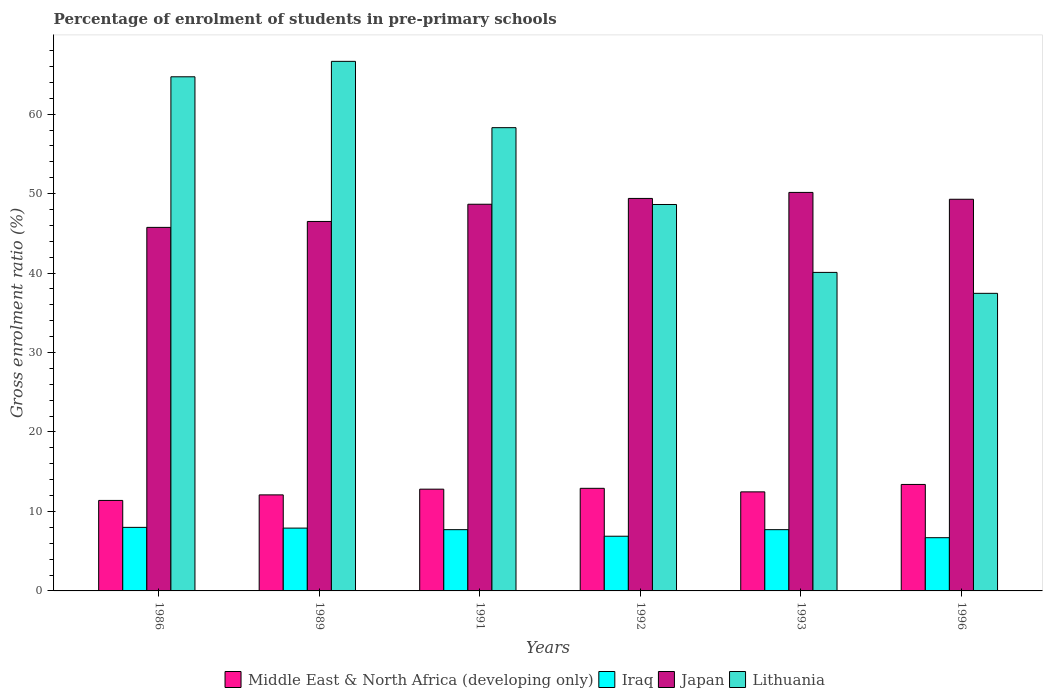How many different coloured bars are there?
Give a very brief answer. 4. Are the number of bars on each tick of the X-axis equal?
Offer a terse response. Yes. How many bars are there on the 2nd tick from the right?
Give a very brief answer. 4. What is the label of the 1st group of bars from the left?
Keep it short and to the point. 1986. What is the percentage of students enrolled in pre-primary schools in Lithuania in 1991?
Give a very brief answer. 58.29. Across all years, what is the maximum percentage of students enrolled in pre-primary schools in Japan?
Give a very brief answer. 50.15. Across all years, what is the minimum percentage of students enrolled in pre-primary schools in Lithuania?
Your answer should be very brief. 37.45. In which year was the percentage of students enrolled in pre-primary schools in Iraq maximum?
Make the answer very short. 1986. In which year was the percentage of students enrolled in pre-primary schools in Middle East & North Africa (developing only) minimum?
Your answer should be very brief. 1986. What is the total percentage of students enrolled in pre-primary schools in Japan in the graph?
Give a very brief answer. 289.72. What is the difference between the percentage of students enrolled in pre-primary schools in Japan in 1989 and that in 1996?
Ensure brevity in your answer.  -2.79. What is the difference between the percentage of students enrolled in pre-primary schools in Lithuania in 1992 and the percentage of students enrolled in pre-primary schools in Japan in 1993?
Provide a short and direct response. -1.52. What is the average percentage of students enrolled in pre-primary schools in Middle East & North Africa (developing only) per year?
Your response must be concise. 12.51. In the year 1996, what is the difference between the percentage of students enrolled in pre-primary schools in Iraq and percentage of students enrolled in pre-primary schools in Middle East & North Africa (developing only)?
Ensure brevity in your answer.  -6.7. In how many years, is the percentage of students enrolled in pre-primary schools in Japan greater than 16 %?
Give a very brief answer. 6. What is the ratio of the percentage of students enrolled in pre-primary schools in Iraq in 1989 to that in 1992?
Ensure brevity in your answer.  1.15. Is the percentage of students enrolled in pre-primary schools in Lithuania in 1986 less than that in 1992?
Provide a succinct answer. No. Is the difference between the percentage of students enrolled in pre-primary schools in Iraq in 1991 and 1992 greater than the difference between the percentage of students enrolled in pre-primary schools in Middle East & North Africa (developing only) in 1991 and 1992?
Your answer should be very brief. Yes. What is the difference between the highest and the second highest percentage of students enrolled in pre-primary schools in Japan?
Make the answer very short. 0.76. What is the difference between the highest and the lowest percentage of students enrolled in pre-primary schools in Middle East & North Africa (developing only)?
Your response must be concise. 2.01. In how many years, is the percentage of students enrolled in pre-primary schools in Japan greater than the average percentage of students enrolled in pre-primary schools in Japan taken over all years?
Your response must be concise. 4. What does the 4th bar from the left in 1993 represents?
Ensure brevity in your answer.  Lithuania. What does the 3rd bar from the right in 1986 represents?
Your answer should be very brief. Iraq. How many bars are there?
Your answer should be very brief. 24. Are all the bars in the graph horizontal?
Offer a terse response. No. What is the difference between two consecutive major ticks on the Y-axis?
Your response must be concise. 10. Where does the legend appear in the graph?
Offer a very short reply. Bottom center. How are the legend labels stacked?
Your response must be concise. Horizontal. What is the title of the graph?
Keep it short and to the point. Percentage of enrolment of students in pre-primary schools. Does "Austria" appear as one of the legend labels in the graph?
Your answer should be very brief. No. What is the label or title of the X-axis?
Provide a short and direct response. Years. What is the label or title of the Y-axis?
Your response must be concise. Gross enrolment ratio (%). What is the Gross enrolment ratio (%) in Middle East & North Africa (developing only) in 1986?
Provide a short and direct response. 11.39. What is the Gross enrolment ratio (%) in Iraq in 1986?
Offer a very short reply. 8. What is the Gross enrolment ratio (%) of Japan in 1986?
Provide a short and direct response. 45.75. What is the Gross enrolment ratio (%) in Lithuania in 1986?
Offer a terse response. 64.7. What is the Gross enrolment ratio (%) in Middle East & North Africa (developing only) in 1989?
Your answer should be compact. 12.09. What is the Gross enrolment ratio (%) of Iraq in 1989?
Your answer should be very brief. 7.91. What is the Gross enrolment ratio (%) in Japan in 1989?
Make the answer very short. 46.49. What is the Gross enrolment ratio (%) in Lithuania in 1989?
Your answer should be very brief. 66.64. What is the Gross enrolment ratio (%) in Middle East & North Africa (developing only) in 1991?
Keep it short and to the point. 12.8. What is the Gross enrolment ratio (%) of Iraq in 1991?
Keep it short and to the point. 7.71. What is the Gross enrolment ratio (%) in Japan in 1991?
Give a very brief answer. 48.66. What is the Gross enrolment ratio (%) of Lithuania in 1991?
Make the answer very short. 58.29. What is the Gross enrolment ratio (%) of Middle East & North Africa (developing only) in 1992?
Your answer should be very brief. 12.91. What is the Gross enrolment ratio (%) in Iraq in 1992?
Offer a very short reply. 6.88. What is the Gross enrolment ratio (%) in Japan in 1992?
Keep it short and to the point. 49.39. What is the Gross enrolment ratio (%) of Lithuania in 1992?
Make the answer very short. 48.63. What is the Gross enrolment ratio (%) in Middle East & North Africa (developing only) in 1993?
Your answer should be compact. 12.47. What is the Gross enrolment ratio (%) in Iraq in 1993?
Your response must be concise. 7.71. What is the Gross enrolment ratio (%) of Japan in 1993?
Give a very brief answer. 50.15. What is the Gross enrolment ratio (%) in Lithuania in 1993?
Offer a terse response. 40.08. What is the Gross enrolment ratio (%) in Middle East & North Africa (developing only) in 1996?
Offer a terse response. 13.4. What is the Gross enrolment ratio (%) of Iraq in 1996?
Ensure brevity in your answer.  6.7. What is the Gross enrolment ratio (%) in Japan in 1996?
Keep it short and to the point. 49.29. What is the Gross enrolment ratio (%) of Lithuania in 1996?
Keep it short and to the point. 37.45. Across all years, what is the maximum Gross enrolment ratio (%) in Middle East & North Africa (developing only)?
Your answer should be compact. 13.4. Across all years, what is the maximum Gross enrolment ratio (%) of Iraq?
Offer a very short reply. 8. Across all years, what is the maximum Gross enrolment ratio (%) of Japan?
Ensure brevity in your answer.  50.15. Across all years, what is the maximum Gross enrolment ratio (%) of Lithuania?
Give a very brief answer. 66.64. Across all years, what is the minimum Gross enrolment ratio (%) of Middle East & North Africa (developing only)?
Make the answer very short. 11.39. Across all years, what is the minimum Gross enrolment ratio (%) in Iraq?
Your answer should be compact. 6.7. Across all years, what is the minimum Gross enrolment ratio (%) in Japan?
Keep it short and to the point. 45.75. Across all years, what is the minimum Gross enrolment ratio (%) of Lithuania?
Provide a succinct answer. 37.45. What is the total Gross enrolment ratio (%) of Middle East & North Africa (developing only) in the graph?
Ensure brevity in your answer.  75.05. What is the total Gross enrolment ratio (%) in Iraq in the graph?
Give a very brief answer. 44.9. What is the total Gross enrolment ratio (%) of Japan in the graph?
Your answer should be very brief. 289.72. What is the total Gross enrolment ratio (%) in Lithuania in the graph?
Make the answer very short. 315.79. What is the difference between the Gross enrolment ratio (%) of Middle East & North Africa (developing only) in 1986 and that in 1989?
Your answer should be very brief. -0.7. What is the difference between the Gross enrolment ratio (%) of Iraq in 1986 and that in 1989?
Provide a succinct answer. 0.09. What is the difference between the Gross enrolment ratio (%) of Japan in 1986 and that in 1989?
Offer a terse response. -0.75. What is the difference between the Gross enrolment ratio (%) of Lithuania in 1986 and that in 1989?
Offer a terse response. -1.94. What is the difference between the Gross enrolment ratio (%) in Middle East & North Africa (developing only) in 1986 and that in 1991?
Provide a succinct answer. -1.42. What is the difference between the Gross enrolment ratio (%) of Iraq in 1986 and that in 1991?
Ensure brevity in your answer.  0.29. What is the difference between the Gross enrolment ratio (%) in Japan in 1986 and that in 1991?
Provide a succinct answer. -2.91. What is the difference between the Gross enrolment ratio (%) of Lithuania in 1986 and that in 1991?
Your answer should be very brief. 6.4. What is the difference between the Gross enrolment ratio (%) of Middle East & North Africa (developing only) in 1986 and that in 1992?
Ensure brevity in your answer.  -1.52. What is the difference between the Gross enrolment ratio (%) in Iraq in 1986 and that in 1992?
Your answer should be compact. 1.12. What is the difference between the Gross enrolment ratio (%) of Japan in 1986 and that in 1992?
Keep it short and to the point. -3.64. What is the difference between the Gross enrolment ratio (%) of Lithuania in 1986 and that in 1992?
Provide a short and direct response. 16.07. What is the difference between the Gross enrolment ratio (%) of Middle East & North Africa (developing only) in 1986 and that in 1993?
Keep it short and to the point. -1.08. What is the difference between the Gross enrolment ratio (%) of Iraq in 1986 and that in 1993?
Offer a very short reply. 0.29. What is the difference between the Gross enrolment ratio (%) in Japan in 1986 and that in 1993?
Provide a succinct answer. -4.4. What is the difference between the Gross enrolment ratio (%) in Lithuania in 1986 and that in 1993?
Provide a succinct answer. 24.61. What is the difference between the Gross enrolment ratio (%) in Middle East & North Africa (developing only) in 1986 and that in 1996?
Offer a terse response. -2.01. What is the difference between the Gross enrolment ratio (%) in Iraq in 1986 and that in 1996?
Give a very brief answer. 1.3. What is the difference between the Gross enrolment ratio (%) of Japan in 1986 and that in 1996?
Your answer should be compact. -3.54. What is the difference between the Gross enrolment ratio (%) of Lithuania in 1986 and that in 1996?
Keep it short and to the point. 27.25. What is the difference between the Gross enrolment ratio (%) of Middle East & North Africa (developing only) in 1989 and that in 1991?
Offer a very short reply. -0.72. What is the difference between the Gross enrolment ratio (%) of Iraq in 1989 and that in 1991?
Your answer should be very brief. 0.2. What is the difference between the Gross enrolment ratio (%) in Japan in 1989 and that in 1991?
Offer a terse response. -2.17. What is the difference between the Gross enrolment ratio (%) in Lithuania in 1989 and that in 1991?
Offer a terse response. 8.35. What is the difference between the Gross enrolment ratio (%) of Middle East & North Africa (developing only) in 1989 and that in 1992?
Provide a succinct answer. -0.83. What is the difference between the Gross enrolment ratio (%) in Iraq in 1989 and that in 1992?
Ensure brevity in your answer.  1.02. What is the difference between the Gross enrolment ratio (%) in Japan in 1989 and that in 1992?
Provide a succinct answer. -2.9. What is the difference between the Gross enrolment ratio (%) in Lithuania in 1989 and that in 1992?
Offer a very short reply. 18.01. What is the difference between the Gross enrolment ratio (%) in Middle East & North Africa (developing only) in 1989 and that in 1993?
Your answer should be very brief. -0.38. What is the difference between the Gross enrolment ratio (%) in Iraq in 1989 and that in 1993?
Keep it short and to the point. 0.2. What is the difference between the Gross enrolment ratio (%) of Japan in 1989 and that in 1993?
Ensure brevity in your answer.  -3.65. What is the difference between the Gross enrolment ratio (%) of Lithuania in 1989 and that in 1993?
Ensure brevity in your answer.  26.56. What is the difference between the Gross enrolment ratio (%) in Middle East & North Africa (developing only) in 1989 and that in 1996?
Offer a very short reply. -1.31. What is the difference between the Gross enrolment ratio (%) of Iraq in 1989 and that in 1996?
Your answer should be compact. 1.21. What is the difference between the Gross enrolment ratio (%) of Japan in 1989 and that in 1996?
Offer a very short reply. -2.79. What is the difference between the Gross enrolment ratio (%) in Lithuania in 1989 and that in 1996?
Offer a very short reply. 29.19. What is the difference between the Gross enrolment ratio (%) of Middle East & North Africa (developing only) in 1991 and that in 1992?
Your response must be concise. -0.11. What is the difference between the Gross enrolment ratio (%) in Iraq in 1991 and that in 1992?
Offer a very short reply. 0.83. What is the difference between the Gross enrolment ratio (%) of Japan in 1991 and that in 1992?
Give a very brief answer. -0.73. What is the difference between the Gross enrolment ratio (%) in Lithuania in 1991 and that in 1992?
Your answer should be compact. 9.67. What is the difference between the Gross enrolment ratio (%) in Middle East & North Africa (developing only) in 1991 and that in 1993?
Offer a terse response. 0.34. What is the difference between the Gross enrolment ratio (%) in Iraq in 1991 and that in 1993?
Ensure brevity in your answer.  0. What is the difference between the Gross enrolment ratio (%) of Japan in 1991 and that in 1993?
Offer a very short reply. -1.49. What is the difference between the Gross enrolment ratio (%) of Lithuania in 1991 and that in 1993?
Provide a succinct answer. 18.21. What is the difference between the Gross enrolment ratio (%) of Middle East & North Africa (developing only) in 1991 and that in 1996?
Your answer should be very brief. -0.59. What is the difference between the Gross enrolment ratio (%) of Japan in 1991 and that in 1996?
Offer a terse response. -0.63. What is the difference between the Gross enrolment ratio (%) of Lithuania in 1991 and that in 1996?
Provide a short and direct response. 20.85. What is the difference between the Gross enrolment ratio (%) in Middle East & North Africa (developing only) in 1992 and that in 1993?
Offer a terse response. 0.45. What is the difference between the Gross enrolment ratio (%) of Iraq in 1992 and that in 1993?
Provide a short and direct response. -0.83. What is the difference between the Gross enrolment ratio (%) in Japan in 1992 and that in 1993?
Provide a succinct answer. -0.76. What is the difference between the Gross enrolment ratio (%) of Lithuania in 1992 and that in 1993?
Make the answer very short. 8.54. What is the difference between the Gross enrolment ratio (%) of Middle East & North Africa (developing only) in 1992 and that in 1996?
Your answer should be very brief. -0.49. What is the difference between the Gross enrolment ratio (%) of Iraq in 1992 and that in 1996?
Offer a terse response. 0.18. What is the difference between the Gross enrolment ratio (%) in Japan in 1992 and that in 1996?
Your answer should be compact. 0.1. What is the difference between the Gross enrolment ratio (%) in Lithuania in 1992 and that in 1996?
Provide a short and direct response. 11.18. What is the difference between the Gross enrolment ratio (%) in Middle East & North Africa (developing only) in 1993 and that in 1996?
Provide a short and direct response. -0.93. What is the difference between the Gross enrolment ratio (%) of Iraq in 1993 and that in 1996?
Provide a succinct answer. 1.01. What is the difference between the Gross enrolment ratio (%) of Japan in 1993 and that in 1996?
Offer a very short reply. 0.86. What is the difference between the Gross enrolment ratio (%) of Lithuania in 1993 and that in 1996?
Offer a terse response. 2.63. What is the difference between the Gross enrolment ratio (%) of Middle East & North Africa (developing only) in 1986 and the Gross enrolment ratio (%) of Iraq in 1989?
Keep it short and to the point. 3.48. What is the difference between the Gross enrolment ratio (%) in Middle East & North Africa (developing only) in 1986 and the Gross enrolment ratio (%) in Japan in 1989?
Provide a succinct answer. -35.11. What is the difference between the Gross enrolment ratio (%) in Middle East & North Africa (developing only) in 1986 and the Gross enrolment ratio (%) in Lithuania in 1989?
Provide a succinct answer. -55.25. What is the difference between the Gross enrolment ratio (%) of Iraq in 1986 and the Gross enrolment ratio (%) of Japan in 1989?
Keep it short and to the point. -38.5. What is the difference between the Gross enrolment ratio (%) in Iraq in 1986 and the Gross enrolment ratio (%) in Lithuania in 1989?
Provide a succinct answer. -58.64. What is the difference between the Gross enrolment ratio (%) in Japan in 1986 and the Gross enrolment ratio (%) in Lithuania in 1989?
Your response must be concise. -20.89. What is the difference between the Gross enrolment ratio (%) of Middle East & North Africa (developing only) in 1986 and the Gross enrolment ratio (%) of Iraq in 1991?
Provide a succinct answer. 3.68. What is the difference between the Gross enrolment ratio (%) in Middle East & North Africa (developing only) in 1986 and the Gross enrolment ratio (%) in Japan in 1991?
Your answer should be compact. -37.27. What is the difference between the Gross enrolment ratio (%) in Middle East & North Africa (developing only) in 1986 and the Gross enrolment ratio (%) in Lithuania in 1991?
Your answer should be compact. -46.91. What is the difference between the Gross enrolment ratio (%) in Iraq in 1986 and the Gross enrolment ratio (%) in Japan in 1991?
Offer a very short reply. -40.66. What is the difference between the Gross enrolment ratio (%) of Iraq in 1986 and the Gross enrolment ratio (%) of Lithuania in 1991?
Give a very brief answer. -50.3. What is the difference between the Gross enrolment ratio (%) in Japan in 1986 and the Gross enrolment ratio (%) in Lithuania in 1991?
Provide a short and direct response. -12.55. What is the difference between the Gross enrolment ratio (%) of Middle East & North Africa (developing only) in 1986 and the Gross enrolment ratio (%) of Iraq in 1992?
Make the answer very short. 4.51. What is the difference between the Gross enrolment ratio (%) of Middle East & North Africa (developing only) in 1986 and the Gross enrolment ratio (%) of Japan in 1992?
Provide a short and direct response. -38. What is the difference between the Gross enrolment ratio (%) of Middle East & North Africa (developing only) in 1986 and the Gross enrolment ratio (%) of Lithuania in 1992?
Make the answer very short. -37.24. What is the difference between the Gross enrolment ratio (%) in Iraq in 1986 and the Gross enrolment ratio (%) in Japan in 1992?
Make the answer very short. -41.39. What is the difference between the Gross enrolment ratio (%) of Iraq in 1986 and the Gross enrolment ratio (%) of Lithuania in 1992?
Give a very brief answer. -40.63. What is the difference between the Gross enrolment ratio (%) of Japan in 1986 and the Gross enrolment ratio (%) of Lithuania in 1992?
Provide a short and direct response. -2.88. What is the difference between the Gross enrolment ratio (%) of Middle East & North Africa (developing only) in 1986 and the Gross enrolment ratio (%) of Iraq in 1993?
Your answer should be very brief. 3.68. What is the difference between the Gross enrolment ratio (%) of Middle East & North Africa (developing only) in 1986 and the Gross enrolment ratio (%) of Japan in 1993?
Provide a succinct answer. -38.76. What is the difference between the Gross enrolment ratio (%) of Middle East & North Africa (developing only) in 1986 and the Gross enrolment ratio (%) of Lithuania in 1993?
Your answer should be very brief. -28.69. What is the difference between the Gross enrolment ratio (%) in Iraq in 1986 and the Gross enrolment ratio (%) in Japan in 1993?
Your answer should be compact. -42.15. What is the difference between the Gross enrolment ratio (%) in Iraq in 1986 and the Gross enrolment ratio (%) in Lithuania in 1993?
Your answer should be compact. -32.09. What is the difference between the Gross enrolment ratio (%) in Japan in 1986 and the Gross enrolment ratio (%) in Lithuania in 1993?
Provide a succinct answer. 5.66. What is the difference between the Gross enrolment ratio (%) of Middle East & North Africa (developing only) in 1986 and the Gross enrolment ratio (%) of Iraq in 1996?
Provide a short and direct response. 4.69. What is the difference between the Gross enrolment ratio (%) of Middle East & North Africa (developing only) in 1986 and the Gross enrolment ratio (%) of Japan in 1996?
Your response must be concise. -37.9. What is the difference between the Gross enrolment ratio (%) in Middle East & North Africa (developing only) in 1986 and the Gross enrolment ratio (%) in Lithuania in 1996?
Provide a succinct answer. -26.06. What is the difference between the Gross enrolment ratio (%) in Iraq in 1986 and the Gross enrolment ratio (%) in Japan in 1996?
Provide a short and direct response. -41.29. What is the difference between the Gross enrolment ratio (%) of Iraq in 1986 and the Gross enrolment ratio (%) of Lithuania in 1996?
Your answer should be compact. -29.45. What is the difference between the Gross enrolment ratio (%) of Japan in 1986 and the Gross enrolment ratio (%) of Lithuania in 1996?
Ensure brevity in your answer.  8.3. What is the difference between the Gross enrolment ratio (%) of Middle East & North Africa (developing only) in 1989 and the Gross enrolment ratio (%) of Iraq in 1991?
Your answer should be very brief. 4.38. What is the difference between the Gross enrolment ratio (%) in Middle East & North Africa (developing only) in 1989 and the Gross enrolment ratio (%) in Japan in 1991?
Provide a succinct answer. -36.57. What is the difference between the Gross enrolment ratio (%) of Middle East & North Africa (developing only) in 1989 and the Gross enrolment ratio (%) of Lithuania in 1991?
Your answer should be compact. -46.21. What is the difference between the Gross enrolment ratio (%) of Iraq in 1989 and the Gross enrolment ratio (%) of Japan in 1991?
Offer a terse response. -40.75. What is the difference between the Gross enrolment ratio (%) in Iraq in 1989 and the Gross enrolment ratio (%) in Lithuania in 1991?
Your response must be concise. -50.39. What is the difference between the Gross enrolment ratio (%) of Japan in 1989 and the Gross enrolment ratio (%) of Lithuania in 1991?
Offer a terse response. -11.8. What is the difference between the Gross enrolment ratio (%) of Middle East & North Africa (developing only) in 1989 and the Gross enrolment ratio (%) of Iraq in 1992?
Ensure brevity in your answer.  5.2. What is the difference between the Gross enrolment ratio (%) of Middle East & North Africa (developing only) in 1989 and the Gross enrolment ratio (%) of Japan in 1992?
Ensure brevity in your answer.  -37.3. What is the difference between the Gross enrolment ratio (%) of Middle East & North Africa (developing only) in 1989 and the Gross enrolment ratio (%) of Lithuania in 1992?
Your answer should be compact. -36.54. What is the difference between the Gross enrolment ratio (%) in Iraq in 1989 and the Gross enrolment ratio (%) in Japan in 1992?
Offer a terse response. -41.48. What is the difference between the Gross enrolment ratio (%) of Iraq in 1989 and the Gross enrolment ratio (%) of Lithuania in 1992?
Provide a short and direct response. -40.72. What is the difference between the Gross enrolment ratio (%) in Japan in 1989 and the Gross enrolment ratio (%) in Lithuania in 1992?
Make the answer very short. -2.13. What is the difference between the Gross enrolment ratio (%) of Middle East & North Africa (developing only) in 1989 and the Gross enrolment ratio (%) of Iraq in 1993?
Offer a terse response. 4.38. What is the difference between the Gross enrolment ratio (%) in Middle East & North Africa (developing only) in 1989 and the Gross enrolment ratio (%) in Japan in 1993?
Offer a terse response. -38.06. What is the difference between the Gross enrolment ratio (%) of Middle East & North Africa (developing only) in 1989 and the Gross enrolment ratio (%) of Lithuania in 1993?
Keep it short and to the point. -28. What is the difference between the Gross enrolment ratio (%) of Iraq in 1989 and the Gross enrolment ratio (%) of Japan in 1993?
Provide a short and direct response. -42.24. What is the difference between the Gross enrolment ratio (%) of Iraq in 1989 and the Gross enrolment ratio (%) of Lithuania in 1993?
Give a very brief answer. -32.18. What is the difference between the Gross enrolment ratio (%) of Japan in 1989 and the Gross enrolment ratio (%) of Lithuania in 1993?
Offer a very short reply. 6.41. What is the difference between the Gross enrolment ratio (%) in Middle East & North Africa (developing only) in 1989 and the Gross enrolment ratio (%) in Iraq in 1996?
Give a very brief answer. 5.39. What is the difference between the Gross enrolment ratio (%) of Middle East & North Africa (developing only) in 1989 and the Gross enrolment ratio (%) of Japan in 1996?
Your response must be concise. -37.2. What is the difference between the Gross enrolment ratio (%) of Middle East & North Africa (developing only) in 1989 and the Gross enrolment ratio (%) of Lithuania in 1996?
Give a very brief answer. -25.36. What is the difference between the Gross enrolment ratio (%) of Iraq in 1989 and the Gross enrolment ratio (%) of Japan in 1996?
Offer a very short reply. -41.38. What is the difference between the Gross enrolment ratio (%) in Iraq in 1989 and the Gross enrolment ratio (%) in Lithuania in 1996?
Your response must be concise. -29.54. What is the difference between the Gross enrolment ratio (%) of Japan in 1989 and the Gross enrolment ratio (%) of Lithuania in 1996?
Ensure brevity in your answer.  9.05. What is the difference between the Gross enrolment ratio (%) of Middle East & North Africa (developing only) in 1991 and the Gross enrolment ratio (%) of Iraq in 1992?
Ensure brevity in your answer.  5.92. What is the difference between the Gross enrolment ratio (%) in Middle East & North Africa (developing only) in 1991 and the Gross enrolment ratio (%) in Japan in 1992?
Offer a very short reply. -36.59. What is the difference between the Gross enrolment ratio (%) of Middle East & North Africa (developing only) in 1991 and the Gross enrolment ratio (%) of Lithuania in 1992?
Your answer should be very brief. -35.82. What is the difference between the Gross enrolment ratio (%) of Iraq in 1991 and the Gross enrolment ratio (%) of Japan in 1992?
Offer a very short reply. -41.68. What is the difference between the Gross enrolment ratio (%) in Iraq in 1991 and the Gross enrolment ratio (%) in Lithuania in 1992?
Offer a terse response. -40.92. What is the difference between the Gross enrolment ratio (%) of Japan in 1991 and the Gross enrolment ratio (%) of Lithuania in 1992?
Ensure brevity in your answer.  0.03. What is the difference between the Gross enrolment ratio (%) in Middle East & North Africa (developing only) in 1991 and the Gross enrolment ratio (%) in Iraq in 1993?
Offer a terse response. 5.1. What is the difference between the Gross enrolment ratio (%) in Middle East & North Africa (developing only) in 1991 and the Gross enrolment ratio (%) in Japan in 1993?
Offer a very short reply. -37.34. What is the difference between the Gross enrolment ratio (%) in Middle East & North Africa (developing only) in 1991 and the Gross enrolment ratio (%) in Lithuania in 1993?
Ensure brevity in your answer.  -27.28. What is the difference between the Gross enrolment ratio (%) in Iraq in 1991 and the Gross enrolment ratio (%) in Japan in 1993?
Offer a terse response. -42.44. What is the difference between the Gross enrolment ratio (%) of Iraq in 1991 and the Gross enrolment ratio (%) of Lithuania in 1993?
Provide a short and direct response. -32.37. What is the difference between the Gross enrolment ratio (%) of Japan in 1991 and the Gross enrolment ratio (%) of Lithuania in 1993?
Make the answer very short. 8.58. What is the difference between the Gross enrolment ratio (%) of Middle East & North Africa (developing only) in 1991 and the Gross enrolment ratio (%) of Iraq in 1996?
Your answer should be very brief. 6.11. What is the difference between the Gross enrolment ratio (%) in Middle East & North Africa (developing only) in 1991 and the Gross enrolment ratio (%) in Japan in 1996?
Offer a terse response. -36.48. What is the difference between the Gross enrolment ratio (%) of Middle East & North Africa (developing only) in 1991 and the Gross enrolment ratio (%) of Lithuania in 1996?
Provide a succinct answer. -24.64. What is the difference between the Gross enrolment ratio (%) of Iraq in 1991 and the Gross enrolment ratio (%) of Japan in 1996?
Offer a very short reply. -41.58. What is the difference between the Gross enrolment ratio (%) in Iraq in 1991 and the Gross enrolment ratio (%) in Lithuania in 1996?
Make the answer very short. -29.74. What is the difference between the Gross enrolment ratio (%) in Japan in 1991 and the Gross enrolment ratio (%) in Lithuania in 1996?
Your answer should be compact. 11.21. What is the difference between the Gross enrolment ratio (%) of Middle East & North Africa (developing only) in 1992 and the Gross enrolment ratio (%) of Iraq in 1993?
Your answer should be compact. 5.2. What is the difference between the Gross enrolment ratio (%) in Middle East & North Africa (developing only) in 1992 and the Gross enrolment ratio (%) in Japan in 1993?
Give a very brief answer. -37.24. What is the difference between the Gross enrolment ratio (%) of Middle East & North Africa (developing only) in 1992 and the Gross enrolment ratio (%) of Lithuania in 1993?
Your answer should be very brief. -27.17. What is the difference between the Gross enrolment ratio (%) of Iraq in 1992 and the Gross enrolment ratio (%) of Japan in 1993?
Offer a terse response. -43.27. What is the difference between the Gross enrolment ratio (%) in Iraq in 1992 and the Gross enrolment ratio (%) in Lithuania in 1993?
Offer a terse response. -33.2. What is the difference between the Gross enrolment ratio (%) in Japan in 1992 and the Gross enrolment ratio (%) in Lithuania in 1993?
Offer a terse response. 9.31. What is the difference between the Gross enrolment ratio (%) of Middle East & North Africa (developing only) in 1992 and the Gross enrolment ratio (%) of Iraq in 1996?
Provide a short and direct response. 6.21. What is the difference between the Gross enrolment ratio (%) in Middle East & North Africa (developing only) in 1992 and the Gross enrolment ratio (%) in Japan in 1996?
Your response must be concise. -36.37. What is the difference between the Gross enrolment ratio (%) of Middle East & North Africa (developing only) in 1992 and the Gross enrolment ratio (%) of Lithuania in 1996?
Your answer should be compact. -24.54. What is the difference between the Gross enrolment ratio (%) in Iraq in 1992 and the Gross enrolment ratio (%) in Japan in 1996?
Provide a short and direct response. -42.4. What is the difference between the Gross enrolment ratio (%) of Iraq in 1992 and the Gross enrolment ratio (%) of Lithuania in 1996?
Make the answer very short. -30.57. What is the difference between the Gross enrolment ratio (%) of Japan in 1992 and the Gross enrolment ratio (%) of Lithuania in 1996?
Offer a terse response. 11.94. What is the difference between the Gross enrolment ratio (%) of Middle East & North Africa (developing only) in 1993 and the Gross enrolment ratio (%) of Iraq in 1996?
Give a very brief answer. 5.77. What is the difference between the Gross enrolment ratio (%) in Middle East & North Africa (developing only) in 1993 and the Gross enrolment ratio (%) in Japan in 1996?
Ensure brevity in your answer.  -36.82. What is the difference between the Gross enrolment ratio (%) in Middle East & North Africa (developing only) in 1993 and the Gross enrolment ratio (%) in Lithuania in 1996?
Your answer should be very brief. -24.98. What is the difference between the Gross enrolment ratio (%) in Iraq in 1993 and the Gross enrolment ratio (%) in Japan in 1996?
Offer a terse response. -41.58. What is the difference between the Gross enrolment ratio (%) of Iraq in 1993 and the Gross enrolment ratio (%) of Lithuania in 1996?
Your answer should be compact. -29.74. What is the average Gross enrolment ratio (%) in Middle East & North Africa (developing only) per year?
Ensure brevity in your answer.  12.51. What is the average Gross enrolment ratio (%) of Iraq per year?
Your answer should be compact. 7.48. What is the average Gross enrolment ratio (%) of Japan per year?
Your response must be concise. 48.29. What is the average Gross enrolment ratio (%) of Lithuania per year?
Your answer should be compact. 52.63. In the year 1986, what is the difference between the Gross enrolment ratio (%) of Middle East & North Africa (developing only) and Gross enrolment ratio (%) of Iraq?
Your answer should be compact. 3.39. In the year 1986, what is the difference between the Gross enrolment ratio (%) in Middle East & North Africa (developing only) and Gross enrolment ratio (%) in Japan?
Your response must be concise. -34.36. In the year 1986, what is the difference between the Gross enrolment ratio (%) of Middle East & North Africa (developing only) and Gross enrolment ratio (%) of Lithuania?
Give a very brief answer. -53.31. In the year 1986, what is the difference between the Gross enrolment ratio (%) in Iraq and Gross enrolment ratio (%) in Japan?
Give a very brief answer. -37.75. In the year 1986, what is the difference between the Gross enrolment ratio (%) of Iraq and Gross enrolment ratio (%) of Lithuania?
Keep it short and to the point. -56.7. In the year 1986, what is the difference between the Gross enrolment ratio (%) of Japan and Gross enrolment ratio (%) of Lithuania?
Provide a succinct answer. -18.95. In the year 1989, what is the difference between the Gross enrolment ratio (%) in Middle East & North Africa (developing only) and Gross enrolment ratio (%) in Iraq?
Your answer should be very brief. 4.18. In the year 1989, what is the difference between the Gross enrolment ratio (%) of Middle East & North Africa (developing only) and Gross enrolment ratio (%) of Japan?
Give a very brief answer. -34.41. In the year 1989, what is the difference between the Gross enrolment ratio (%) in Middle East & North Africa (developing only) and Gross enrolment ratio (%) in Lithuania?
Make the answer very short. -54.55. In the year 1989, what is the difference between the Gross enrolment ratio (%) in Iraq and Gross enrolment ratio (%) in Japan?
Your answer should be compact. -38.59. In the year 1989, what is the difference between the Gross enrolment ratio (%) in Iraq and Gross enrolment ratio (%) in Lithuania?
Your answer should be very brief. -58.73. In the year 1989, what is the difference between the Gross enrolment ratio (%) in Japan and Gross enrolment ratio (%) in Lithuania?
Make the answer very short. -20.15. In the year 1991, what is the difference between the Gross enrolment ratio (%) in Middle East & North Africa (developing only) and Gross enrolment ratio (%) in Iraq?
Provide a short and direct response. 5.1. In the year 1991, what is the difference between the Gross enrolment ratio (%) of Middle East & North Africa (developing only) and Gross enrolment ratio (%) of Japan?
Keep it short and to the point. -35.85. In the year 1991, what is the difference between the Gross enrolment ratio (%) in Middle East & North Africa (developing only) and Gross enrolment ratio (%) in Lithuania?
Give a very brief answer. -45.49. In the year 1991, what is the difference between the Gross enrolment ratio (%) of Iraq and Gross enrolment ratio (%) of Japan?
Your answer should be very brief. -40.95. In the year 1991, what is the difference between the Gross enrolment ratio (%) of Iraq and Gross enrolment ratio (%) of Lithuania?
Give a very brief answer. -50.59. In the year 1991, what is the difference between the Gross enrolment ratio (%) in Japan and Gross enrolment ratio (%) in Lithuania?
Give a very brief answer. -9.64. In the year 1992, what is the difference between the Gross enrolment ratio (%) of Middle East & North Africa (developing only) and Gross enrolment ratio (%) of Iraq?
Keep it short and to the point. 6.03. In the year 1992, what is the difference between the Gross enrolment ratio (%) in Middle East & North Africa (developing only) and Gross enrolment ratio (%) in Japan?
Offer a terse response. -36.48. In the year 1992, what is the difference between the Gross enrolment ratio (%) of Middle East & North Africa (developing only) and Gross enrolment ratio (%) of Lithuania?
Make the answer very short. -35.72. In the year 1992, what is the difference between the Gross enrolment ratio (%) of Iraq and Gross enrolment ratio (%) of Japan?
Provide a succinct answer. -42.51. In the year 1992, what is the difference between the Gross enrolment ratio (%) of Iraq and Gross enrolment ratio (%) of Lithuania?
Offer a very short reply. -41.75. In the year 1992, what is the difference between the Gross enrolment ratio (%) in Japan and Gross enrolment ratio (%) in Lithuania?
Your answer should be very brief. 0.76. In the year 1993, what is the difference between the Gross enrolment ratio (%) in Middle East & North Africa (developing only) and Gross enrolment ratio (%) in Iraq?
Your response must be concise. 4.76. In the year 1993, what is the difference between the Gross enrolment ratio (%) of Middle East & North Africa (developing only) and Gross enrolment ratio (%) of Japan?
Your answer should be compact. -37.68. In the year 1993, what is the difference between the Gross enrolment ratio (%) of Middle East & North Africa (developing only) and Gross enrolment ratio (%) of Lithuania?
Ensure brevity in your answer.  -27.62. In the year 1993, what is the difference between the Gross enrolment ratio (%) of Iraq and Gross enrolment ratio (%) of Japan?
Keep it short and to the point. -42.44. In the year 1993, what is the difference between the Gross enrolment ratio (%) of Iraq and Gross enrolment ratio (%) of Lithuania?
Provide a succinct answer. -32.37. In the year 1993, what is the difference between the Gross enrolment ratio (%) in Japan and Gross enrolment ratio (%) in Lithuania?
Give a very brief answer. 10.07. In the year 1996, what is the difference between the Gross enrolment ratio (%) in Middle East & North Africa (developing only) and Gross enrolment ratio (%) in Iraq?
Offer a terse response. 6.7. In the year 1996, what is the difference between the Gross enrolment ratio (%) in Middle East & North Africa (developing only) and Gross enrolment ratio (%) in Japan?
Keep it short and to the point. -35.89. In the year 1996, what is the difference between the Gross enrolment ratio (%) in Middle East & North Africa (developing only) and Gross enrolment ratio (%) in Lithuania?
Provide a succinct answer. -24.05. In the year 1996, what is the difference between the Gross enrolment ratio (%) of Iraq and Gross enrolment ratio (%) of Japan?
Provide a succinct answer. -42.59. In the year 1996, what is the difference between the Gross enrolment ratio (%) in Iraq and Gross enrolment ratio (%) in Lithuania?
Provide a succinct answer. -30.75. In the year 1996, what is the difference between the Gross enrolment ratio (%) in Japan and Gross enrolment ratio (%) in Lithuania?
Ensure brevity in your answer.  11.84. What is the ratio of the Gross enrolment ratio (%) of Middle East & North Africa (developing only) in 1986 to that in 1989?
Make the answer very short. 0.94. What is the ratio of the Gross enrolment ratio (%) of Iraq in 1986 to that in 1989?
Offer a very short reply. 1.01. What is the ratio of the Gross enrolment ratio (%) of Japan in 1986 to that in 1989?
Your answer should be very brief. 0.98. What is the ratio of the Gross enrolment ratio (%) of Lithuania in 1986 to that in 1989?
Your response must be concise. 0.97. What is the ratio of the Gross enrolment ratio (%) of Middle East & North Africa (developing only) in 1986 to that in 1991?
Keep it short and to the point. 0.89. What is the ratio of the Gross enrolment ratio (%) of Iraq in 1986 to that in 1991?
Your answer should be compact. 1.04. What is the ratio of the Gross enrolment ratio (%) of Japan in 1986 to that in 1991?
Give a very brief answer. 0.94. What is the ratio of the Gross enrolment ratio (%) of Lithuania in 1986 to that in 1991?
Provide a succinct answer. 1.11. What is the ratio of the Gross enrolment ratio (%) of Middle East & North Africa (developing only) in 1986 to that in 1992?
Give a very brief answer. 0.88. What is the ratio of the Gross enrolment ratio (%) in Iraq in 1986 to that in 1992?
Give a very brief answer. 1.16. What is the ratio of the Gross enrolment ratio (%) in Japan in 1986 to that in 1992?
Keep it short and to the point. 0.93. What is the ratio of the Gross enrolment ratio (%) in Lithuania in 1986 to that in 1992?
Make the answer very short. 1.33. What is the ratio of the Gross enrolment ratio (%) of Middle East & North Africa (developing only) in 1986 to that in 1993?
Your answer should be very brief. 0.91. What is the ratio of the Gross enrolment ratio (%) of Iraq in 1986 to that in 1993?
Make the answer very short. 1.04. What is the ratio of the Gross enrolment ratio (%) in Japan in 1986 to that in 1993?
Provide a short and direct response. 0.91. What is the ratio of the Gross enrolment ratio (%) of Lithuania in 1986 to that in 1993?
Offer a very short reply. 1.61. What is the ratio of the Gross enrolment ratio (%) of Middle East & North Africa (developing only) in 1986 to that in 1996?
Your answer should be very brief. 0.85. What is the ratio of the Gross enrolment ratio (%) of Iraq in 1986 to that in 1996?
Provide a short and direct response. 1.19. What is the ratio of the Gross enrolment ratio (%) in Japan in 1986 to that in 1996?
Your answer should be compact. 0.93. What is the ratio of the Gross enrolment ratio (%) in Lithuania in 1986 to that in 1996?
Offer a very short reply. 1.73. What is the ratio of the Gross enrolment ratio (%) of Middle East & North Africa (developing only) in 1989 to that in 1991?
Provide a succinct answer. 0.94. What is the ratio of the Gross enrolment ratio (%) of Iraq in 1989 to that in 1991?
Provide a succinct answer. 1.03. What is the ratio of the Gross enrolment ratio (%) in Japan in 1989 to that in 1991?
Make the answer very short. 0.96. What is the ratio of the Gross enrolment ratio (%) of Lithuania in 1989 to that in 1991?
Offer a terse response. 1.14. What is the ratio of the Gross enrolment ratio (%) in Middle East & North Africa (developing only) in 1989 to that in 1992?
Your answer should be very brief. 0.94. What is the ratio of the Gross enrolment ratio (%) in Iraq in 1989 to that in 1992?
Your answer should be compact. 1.15. What is the ratio of the Gross enrolment ratio (%) in Japan in 1989 to that in 1992?
Your answer should be very brief. 0.94. What is the ratio of the Gross enrolment ratio (%) of Lithuania in 1989 to that in 1992?
Your response must be concise. 1.37. What is the ratio of the Gross enrolment ratio (%) in Middle East & North Africa (developing only) in 1989 to that in 1993?
Provide a short and direct response. 0.97. What is the ratio of the Gross enrolment ratio (%) in Iraq in 1989 to that in 1993?
Your answer should be very brief. 1.03. What is the ratio of the Gross enrolment ratio (%) in Japan in 1989 to that in 1993?
Offer a very short reply. 0.93. What is the ratio of the Gross enrolment ratio (%) in Lithuania in 1989 to that in 1993?
Offer a very short reply. 1.66. What is the ratio of the Gross enrolment ratio (%) in Middle East & North Africa (developing only) in 1989 to that in 1996?
Your answer should be compact. 0.9. What is the ratio of the Gross enrolment ratio (%) of Iraq in 1989 to that in 1996?
Offer a terse response. 1.18. What is the ratio of the Gross enrolment ratio (%) in Japan in 1989 to that in 1996?
Keep it short and to the point. 0.94. What is the ratio of the Gross enrolment ratio (%) in Lithuania in 1989 to that in 1996?
Provide a short and direct response. 1.78. What is the ratio of the Gross enrolment ratio (%) in Iraq in 1991 to that in 1992?
Give a very brief answer. 1.12. What is the ratio of the Gross enrolment ratio (%) in Japan in 1991 to that in 1992?
Provide a short and direct response. 0.99. What is the ratio of the Gross enrolment ratio (%) in Lithuania in 1991 to that in 1992?
Provide a succinct answer. 1.2. What is the ratio of the Gross enrolment ratio (%) in Middle East & North Africa (developing only) in 1991 to that in 1993?
Your answer should be compact. 1.03. What is the ratio of the Gross enrolment ratio (%) of Japan in 1991 to that in 1993?
Ensure brevity in your answer.  0.97. What is the ratio of the Gross enrolment ratio (%) in Lithuania in 1991 to that in 1993?
Provide a succinct answer. 1.45. What is the ratio of the Gross enrolment ratio (%) in Middle East & North Africa (developing only) in 1991 to that in 1996?
Your answer should be very brief. 0.96. What is the ratio of the Gross enrolment ratio (%) in Iraq in 1991 to that in 1996?
Provide a succinct answer. 1.15. What is the ratio of the Gross enrolment ratio (%) in Japan in 1991 to that in 1996?
Ensure brevity in your answer.  0.99. What is the ratio of the Gross enrolment ratio (%) in Lithuania in 1991 to that in 1996?
Keep it short and to the point. 1.56. What is the ratio of the Gross enrolment ratio (%) of Middle East & North Africa (developing only) in 1992 to that in 1993?
Offer a terse response. 1.04. What is the ratio of the Gross enrolment ratio (%) of Iraq in 1992 to that in 1993?
Give a very brief answer. 0.89. What is the ratio of the Gross enrolment ratio (%) in Japan in 1992 to that in 1993?
Provide a short and direct response. 0.98. What is the ratio of the Gross enrolment ratio (%) of Lithuania in 1992 to that in 1993?
Your answer should be very brief. 1.21. What is the ratio of the Gross enrolment ratio (%) of Middle East & North Africa (developing only) in 1992 to that in 1996?
Offer a very short reply. 0.96. What is the ratio of the Gross enrolment ratio (%) of Iraq in 1992 to that in 1996?
Make the answer very short. 1.03. What is the ratio of the Gross enrolment ratio (%) in Lithuania in 1992 to that in 1996?
Your answer should be compact. 1.3. What is the ratio of the Gross enrolment ratio (%) in Middle East & North Africa (developing only) in 1993 to that in 1996?
Keep it short and to the point. 0.93. What is the ratio of the Gross enrolment ratio (%) in Iraq in 1993 to that in 1996?
Make the answer very short. 1.15. What is the ratio of the Gross enrolment ratio (%) in Japan in 1993 to that in 1996?
Make the answer very short. 1.02. What is the ratio of the Gross enrolment ratio (%) of Lithuania in 1993 to that in 1996?
Offer a terse response. 1.07. What is the difference between the highest and the second highest Gross enrolment ratio (%) of Middle East & North Africa (developing only)?
Keep it short and to the point. 0.49. What is the difference between the highest and the second highest Gross enrolment ratio (%) in Iraq?
Make the answer very short. 0.09. What is the difference between the highest and the second highest Gross enrolment ratio (%) in Japan?
Make the answer very short. 0.76. What is the difference between the highest and the second highest Gross enrolment ratio (%) of Lithuania?
Ensure brevity in your answer.  1.94. What is the difference between the highest and the lowest Gross enrolment ratio (%) in Middle East & North Africa (developing only)?
Offer a very short reply. 2.01. What is the difference between the highest and the lowest Gross enrolment ratio (%) of Iraq?
Keep it short and to the point. 1.3. What is the difference between the highest and the lowest Gross enrolment ratio (%) in Japan?
Provide a succinct answer. 4.4. What is the difference between the highest and the lowest Gross enrolment ratio (%) in Lithuania?
Offer a very short reply. 29.19. 